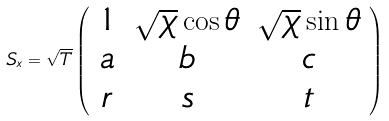<formula> <loc_0><loc_0><loc_500><loc_500>S _ { x } = \sqrt { T } \left ( \begin{array} { c c c } 1 & \sqrt { \chi } \cos \theta & \sqrt { \chi } \sin \theta \\ a & b & c \\ r & s & t \end{array} \right )</formula> 